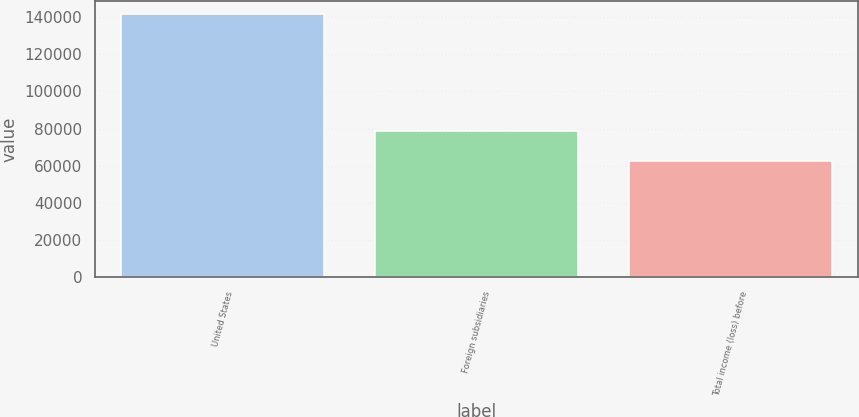Convert chart to OTSL. <chart><loc_0><loc_0><loc_500><loc_500><bar_chart><fcel>United States<fcel>Foreign subsidiaries<fcel>Total income (loss) before<nl><fcel>141726<fcel>78958<fcel>62768<nl></chart> 